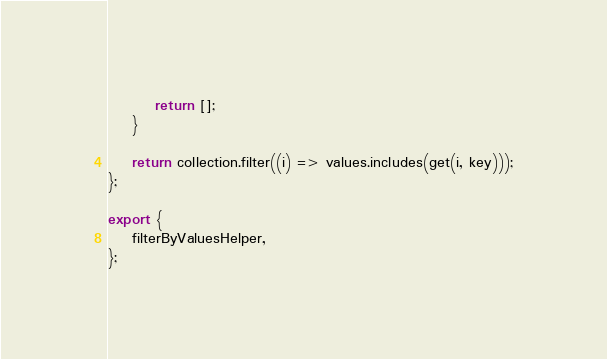<code> <loc_0><loc_0><loc_500><loc_500><_JavaScript_>        return [];
    }

    return collection.filter((i) => values.includes(get(i, key)));
};

export {
    filterByValuesHelper,
};
</code> 